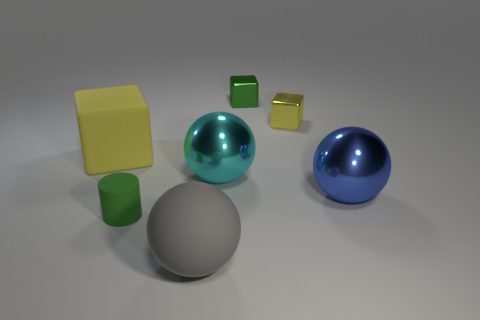There is a small object that is to the left of the tiny green metal cube; does it have the same shape as the large gray object?
Provide a succinct answer. No. There is a yellow cube on the right side of the green cylinder; what material is it?
Provide a succinct answer. Metal. There is a tiny thing that is the same color as the cylinder; what is its shape?
Ensure brevity in your answer.  Cube. Are there any other gray things made of the same material as the big gray object?
Provide a short and direct response. No. What is the size of the matte sphere?
Ensure brevity in your answer.  Large. What number of blue things are either blocks or small cubes?
Your answer should be very brief. 0. What number of other small objects are the same shape as the yellow rubber thing?
Keep it short and to the point. 2. What number of other gray matte things have the same size as the gray object?
Your answer should be very brief. 0. There is a green thing that is the same shape as the large yellow thing; what is its material?
Offer a very short reply. Metal. What is the color of the large rubber object that is left of the large gray thing?
Ensure brevity in your answer.  Yellow. 